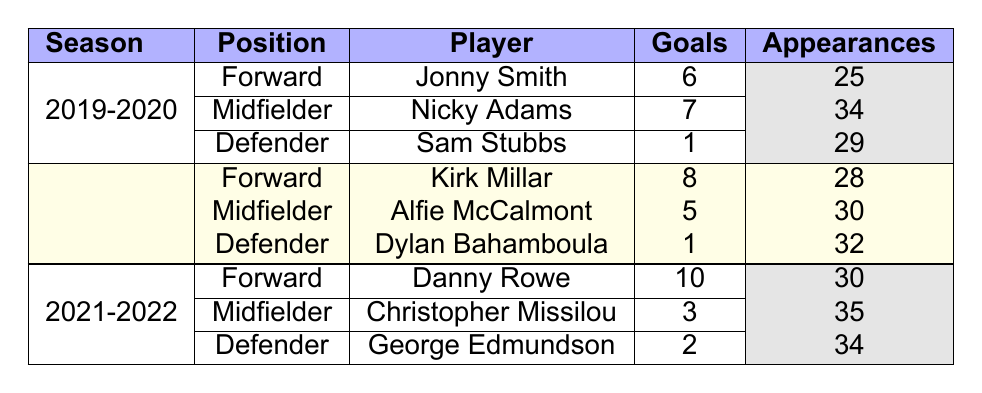What is the total number of goals scored by players in the 2021-2022 season? To find the total goals for the 2021-2022 season, we look at all players in that season: Danny Rowe scored 10 goals, Christopher Missilou scored 3 goals, and George Edmundson scored 2 goals. Adding these gives 10 + 3 + 2 = 15 total goals.
Answer: 15 Which player had the highest number of assists in the 2020-2021 season? In the 2020-2021 season, we check the assists: Kirk Millar had 4, Alfie McCalmont had 3, and Dylan Bahamboula had 2. The highest number of assists is 4 by Kirk Millar.
Answer: Kirk Millar Did any defender score more than one goal in the 2019-2020 season? In the 2019-2020 season, the defenders are Sam Stubbs who scored 1 goal. Since no defender scored more than 1 goal, the answer is no.
Answer: No What is the average number of goals scored by forwards across all three seasons listed? The forwards' goals are: Jonny Smith (6), Kirk Millar (8), and Danny Rowe (10). The total goals is 6 + 8 + 10 = 24. Since there are 3 forwards, the average is 24 / 3 = 8.
Answer: 8 In the 2021-2022 season, how many appearances did the midfielder player have compared to the defender player? In the 2021-2022 season, Christopher Missilou (midfielder) had 35 appearances while George Edmundson (defender) had 34 appearances. Comparing these, Missilou had 1 more appearance than Edmundson.
Answer: 1 more appearance Which season had the fewest goals scored by a midfielder? The goals by midfielders are: Nicky Adams (7) in 2019-2020, Alfie McCalmont (5) in 2020-2021, and Christopher Missilou (3) in 2021-2022. The fewest is 3 by Christopher Missilou in 2021-2022.
Answer: 2021-2022 Can you confirm if Sam Stubbs played more appearances than George Edmundson? Sam Stubbs had 29 appearances and George Edmundson had 34 appearances in their respective seasons. Since 29 is less than 34, it confirms that Sam Stubbs did not play more appearances than George Edmundson.
Answer: No What is the total number of appearances made by players in the 2020-2021 season? For the 2020-2021 season, the appearances are: Kirk Millar (28), Alfie McCalmont (30), and Dylan Bahamboula (32). Adding these gives a total of 28 + 30 + 32 = 90 appearances.
Answer: 90 